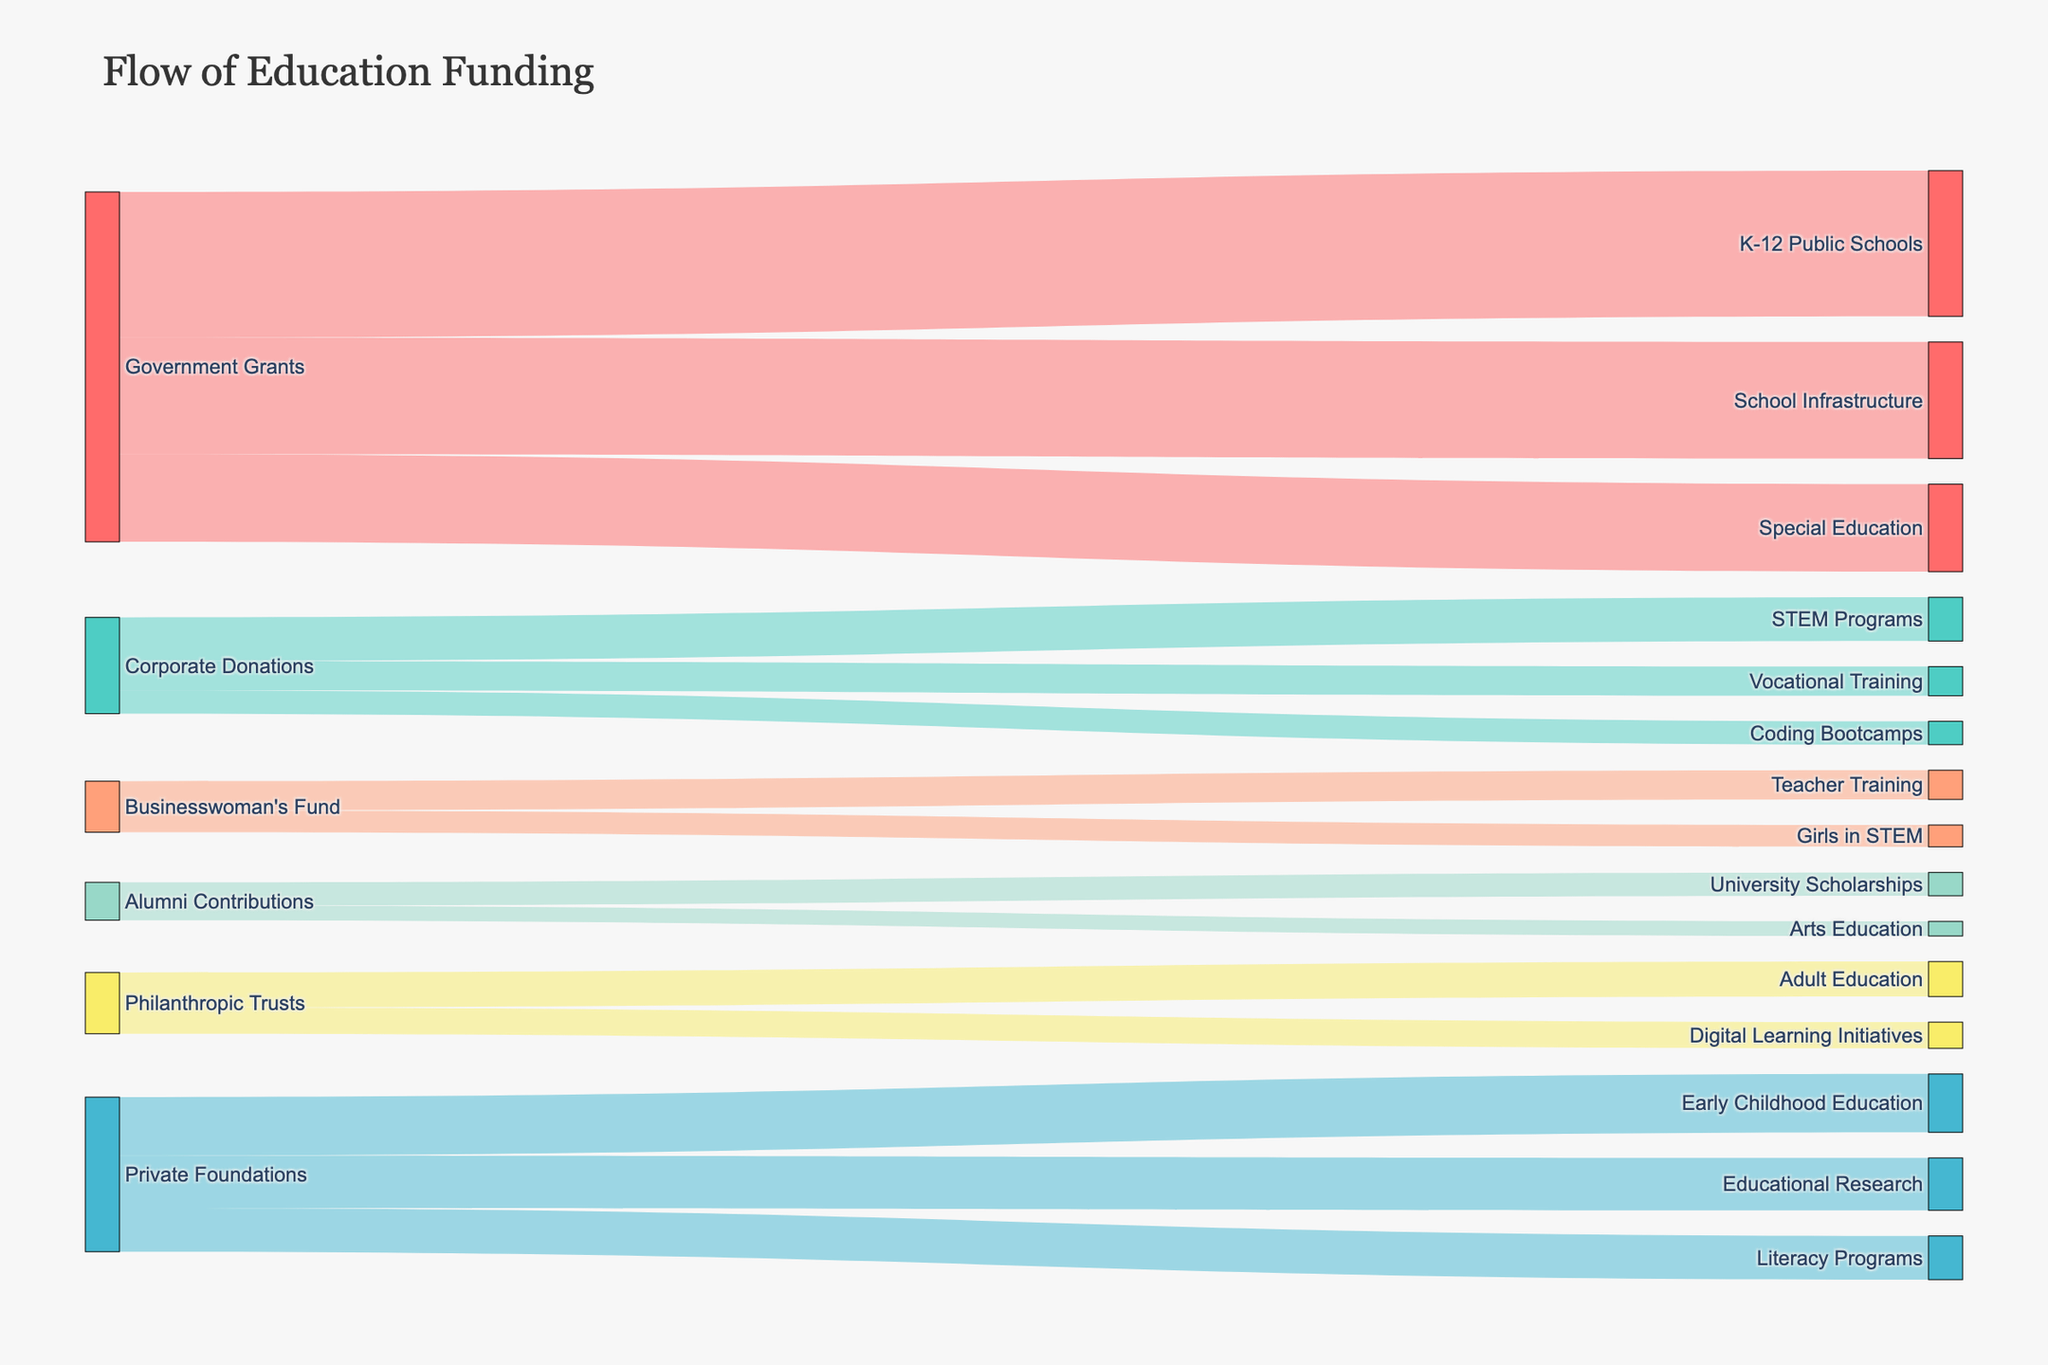Which funding source provides the most funds? By examining the sizes and values of the flows, the Government Grants provide 500, 300, and 400 in three separate flows, which is the highest total amount.
Answer: Government Grants How much total funding comes from Private Foundations? Summing up the values from Private Foundations to different programs: 200 (Early Childhood Education) + 150 (Literacy Programs) + 180 (Educational Research) = 530.
Answer: 530 Which educational program receives the most funding? By examining the target nodes, K-12 Public Schools receive the most funding from Government Grants, which is 500.
Answer: K-12 Public Schools What is the combined funding amount for Teacher Training and Girls in STEM from the Businesswoman's Fund? Summing up the values of flows from the Businesswoman’s Fund to these programs: 100 (Teacher Training) + 75 (Girls in STEM) = 175.
Answer: 175 Which two programs receive funding from both Corporate Donations and Private Foundations? Looking at the target nodes, STEM Programs receive 150 from Corporate Donations, and Literacy Programs receives 150 from Private Foundations.
Answer: None What is the total funding amount from Philanthropic Trusts to educational programs? Summing up the values from Philanthropic Trusts: 120 (Adult Education) + 90 (Digital Learning Initiatives) = 210.
Answer: 210 How does the funding from Government Grants to Special Education compare to the funding from Government Grants to School Infrastructure? Special Education receives 300 from Government Grants, while School Infrastructure receives 400. Thus, the funding for School Infrastructure is greater.
Answer: School Infrastructure Which program receives the least amount of funding? By looking at all the targets and their corresponding values, Arts Education receives the least amount from Alumni Contributions, which is 50.
Answer: Arts Education What is the total amount of funding received by all University Scholarships? University Scholarships receive 80 from Alumni Contributions.
Answer: 80 How many unique sources of funding are there? Counting the unique source nodes in the Sankey diagram, we have Government Grants, Corporate Donations, Private Foundations, Businesswoman's Fund, Alumni Contributions, and Philanthropic Trusts. This gives a total of 6 unique sources.
Answer: 6 